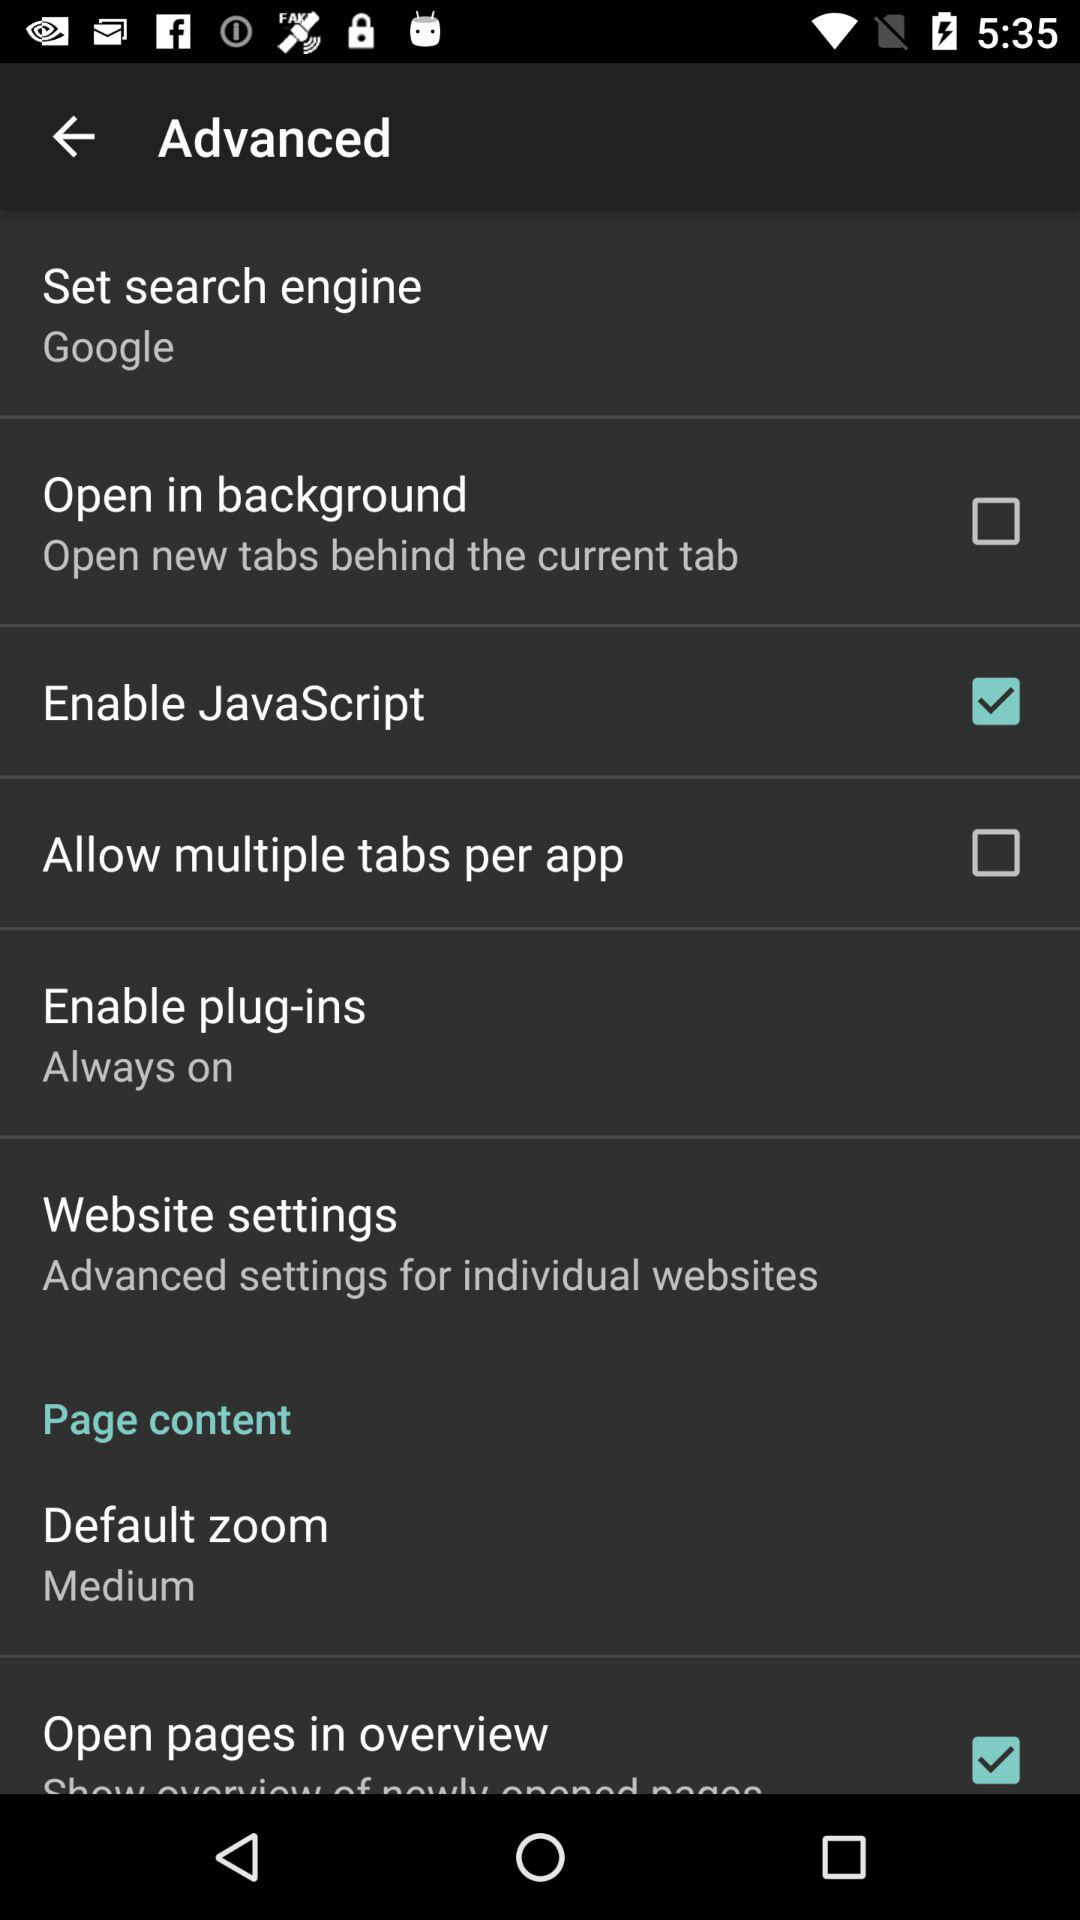What is the setting for the set search engine? The setting for the set search engine is "Google". 